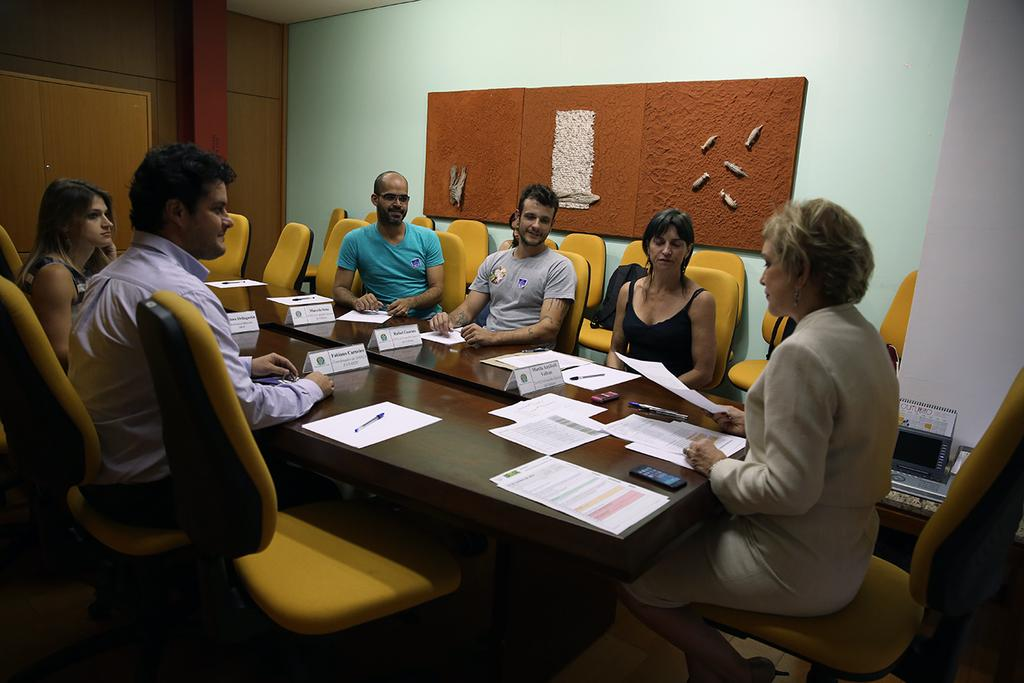Who or what can be seen in the image? There are people in the image. What are the people doing in the image? The people are sitting on chairs. What type of worm can be seen crawling on the notebook in the image? There is no worm or notebook present in the image; it only features people sitting on chairs. 